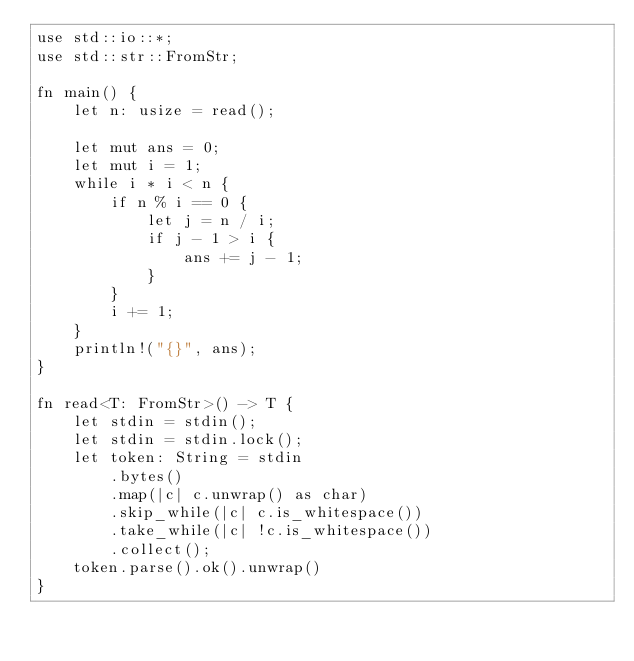<code> <loc_0><loc_0><loc_500><loc_500><_Rust_>use std::io::*;
use std::str::FromStr;

fn main() {
    let n: usize = read();

    let mut ans = 0;
    let mut i = 1;
    while i * i < n {
        if n % i == 0 {
            let j = n / i;
            if j - 1 > i {
                ans += j - 1;
            }
        }
        i += 1;
    }
    println!("{}", ans);
}

fn read<T: FromStr>() -> T {
    let stdin = stdin();
    let stdin = stdin.lock();
    let token: String = stdin
        .bytes()
        .map(|c| c.unwrap() as char)
        .skip_while(|c| c.is_whitespace())
        .take_while(|c| !c.is_whitespace())
        .collect();
    token.parse().ok().unwrap()
}
</code> 